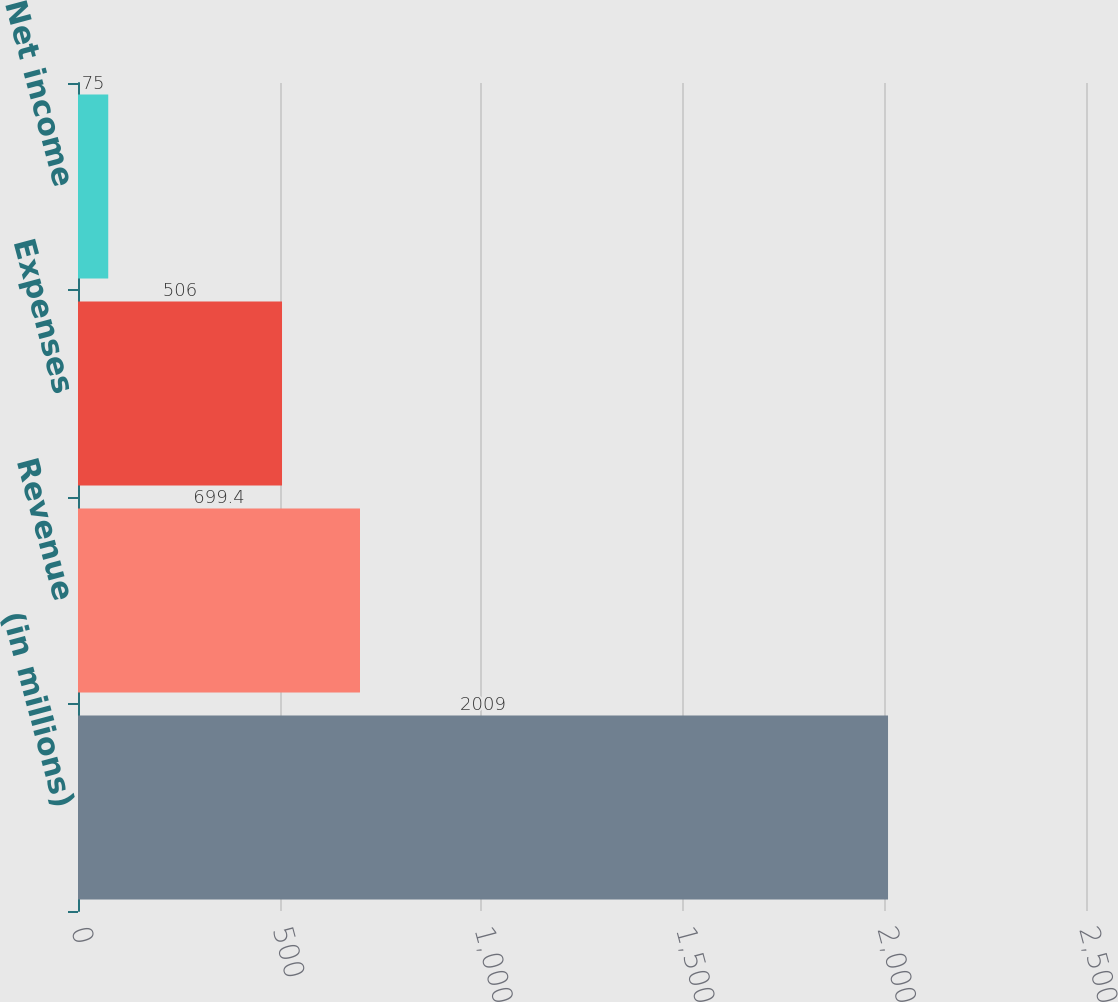Convert chart to OTSL. <chart><loc_0><loc_0><loc_500><loc_500><bar_chart><fcel>(in millions)<fcel>Revenue<fcel>Expenses<fcel>Net income<nl><fcel>2009<fcel>699.4<fcel>506<fcel>75<nl></chart> 